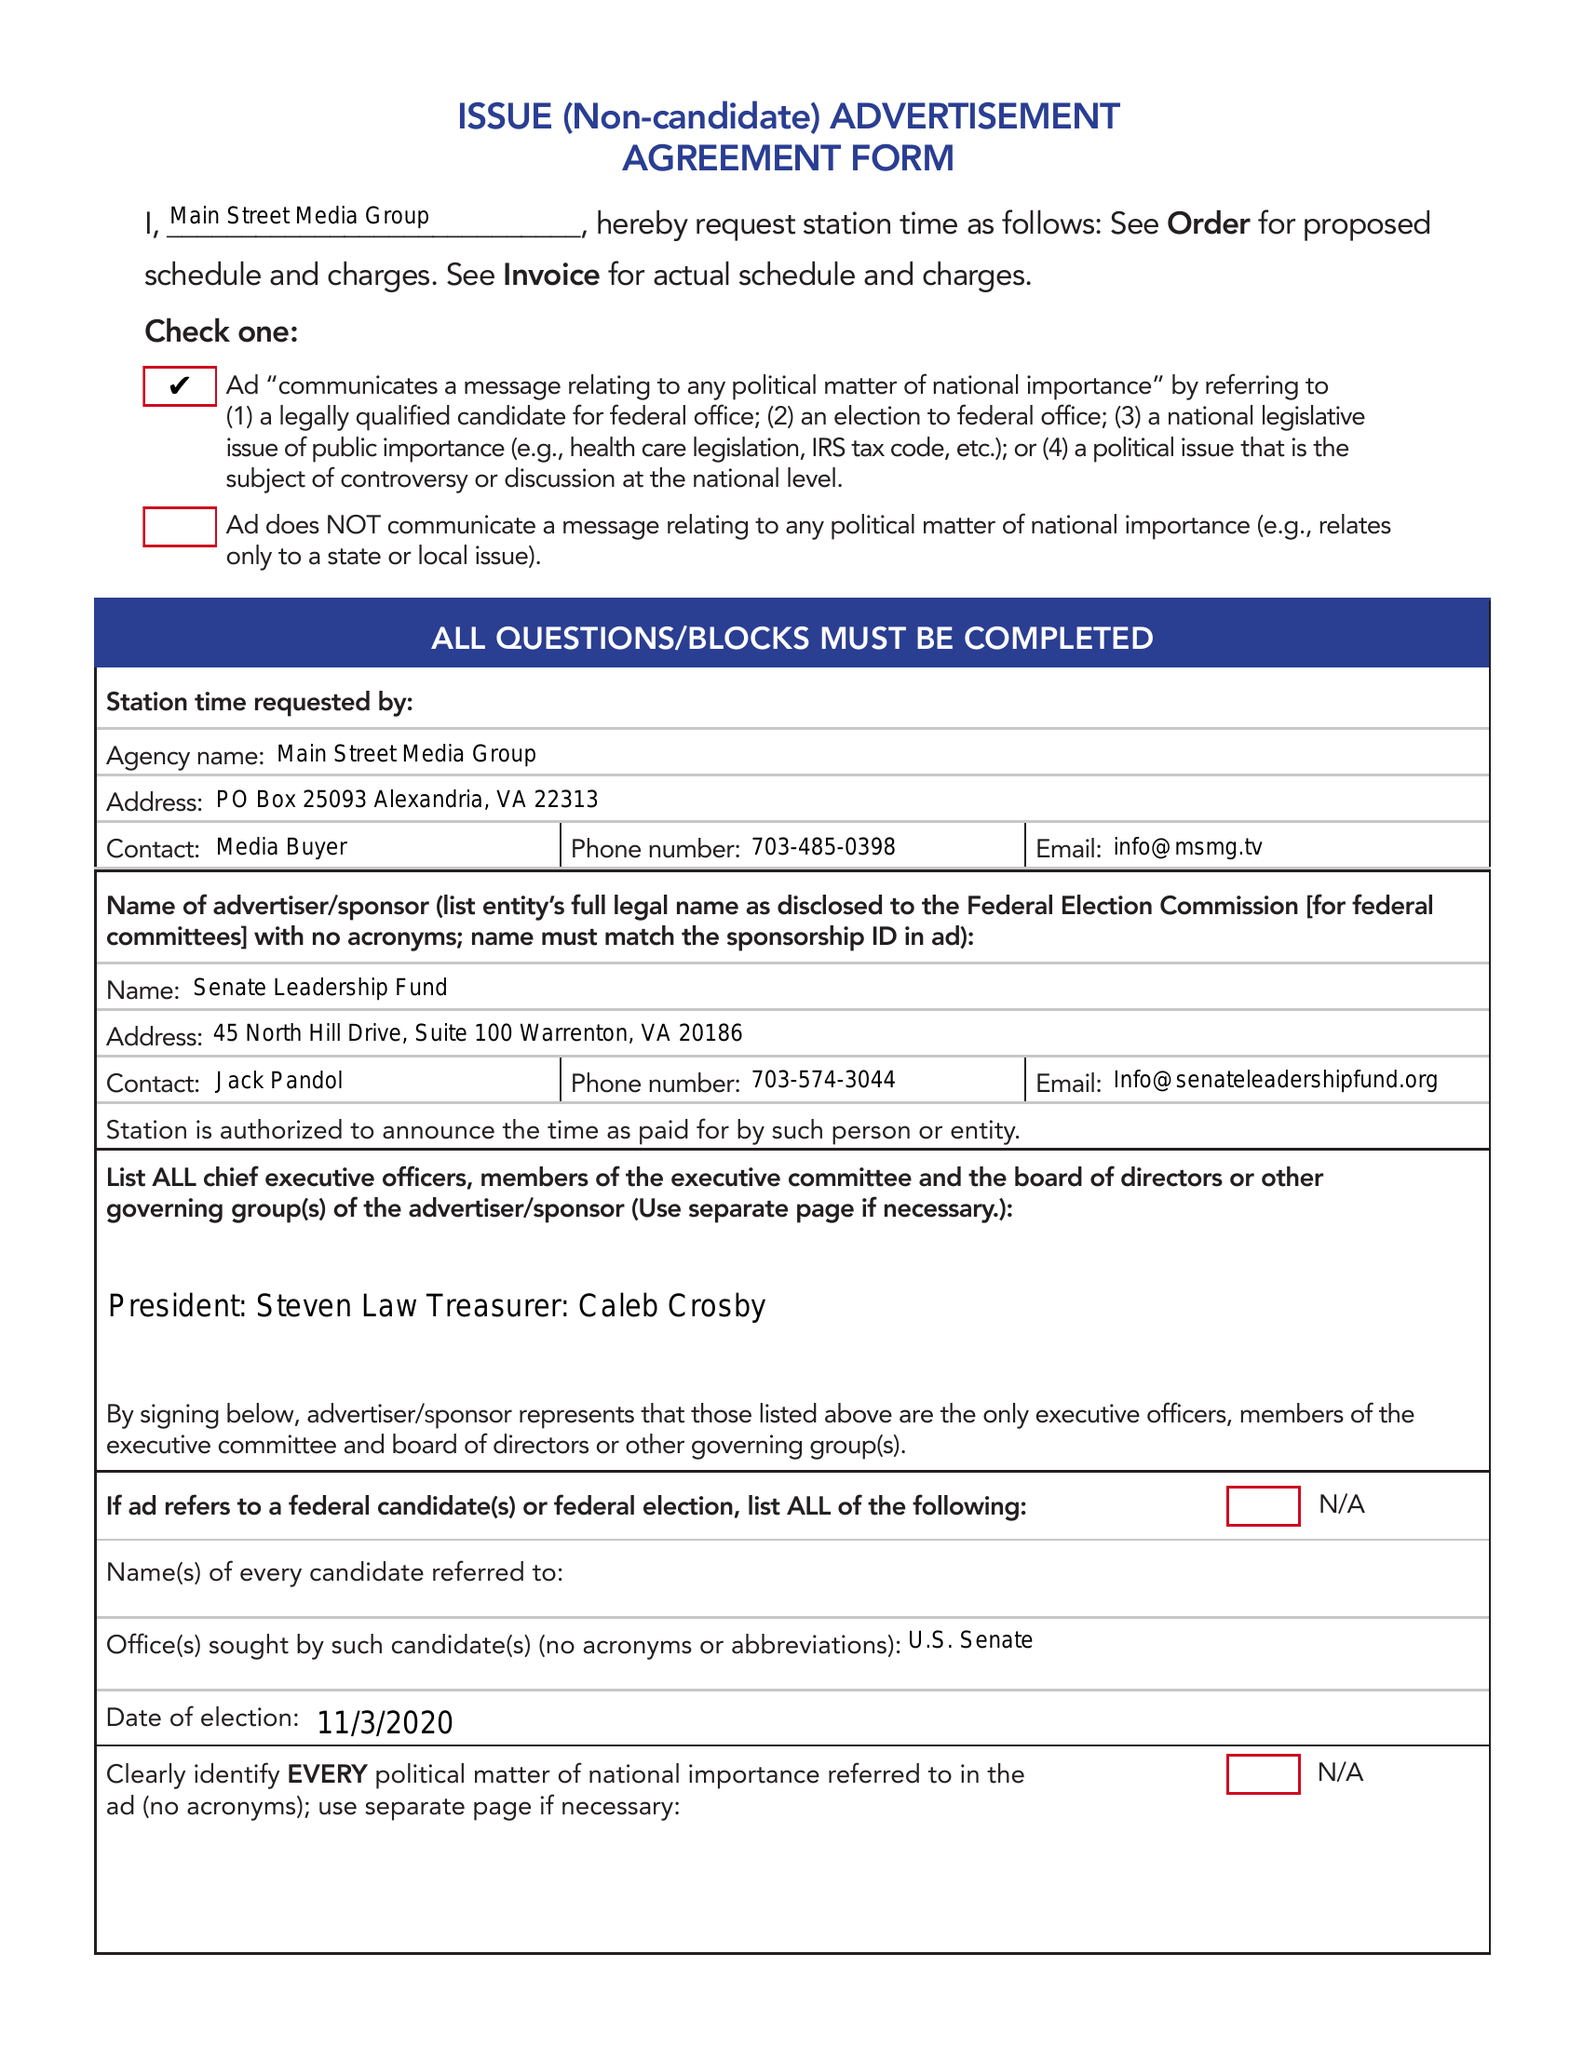What is the value for the flight_to?
Answer the question using a single word or phrase. 10/26/20 